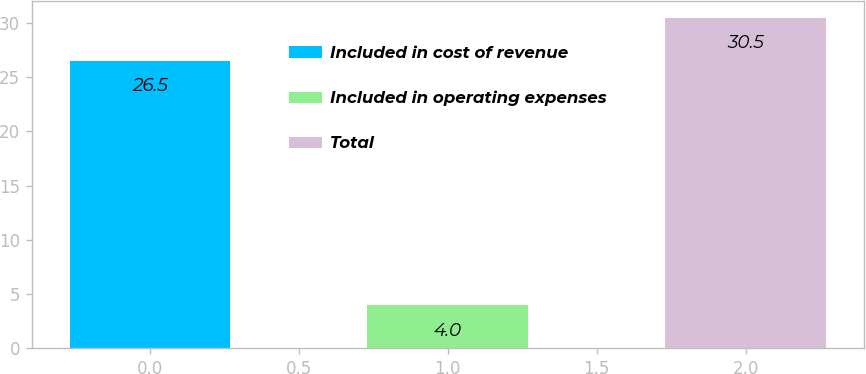Convert chart to OTSL. <chart><loc_0><loc_0><loc_500><loc_500><bar_chart><fcel>Included in cost of revenue<fcel>Included in operating expenses<fcel>Total<nl><fcel>26.5<fcel>4<fcel>30.5<nl></chart> 